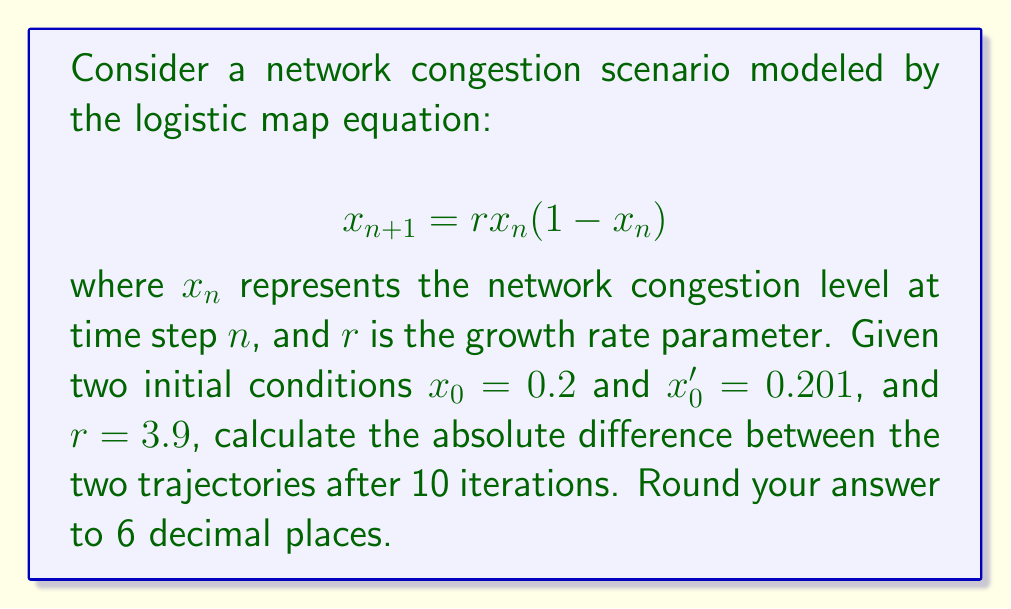Provide a solution to this math problem. To solve this problem, we need to iterate the logistic map equation for both initial conditions and compare the results:

1. For $x_0 = 0.2$:
   $x_1 = 3.9 \times 0.2 \times (1 - 0.2) = 0.624$
   $x_2 = 3.9 \times 0.624 \times (1 - 0.624) = 0.916324416$
   ...
   $x_{10} = 0.870271178$

2. For $x_0' = 0.201$:
   $x_1' = 3.9 \times 0.201 \times (1 - 0.201) = 0.626145$
   $x_2' = 3.9 \times 0.626145 \times (1 - 0.626145) = 0.916988625$
   ...
   $x_{10}' = 0.629372315$

3. Calculate the absolute difference:
   $|x_{10} - x_{10}'| = |0.870271178 - 0.629372315| = 0.240898863$

4. Round to 6 decimal places:
   $0.240898863 \approx 0.240899$

This result demonstrates the sensitivity to initial conditions in chaotic systems, where a small change in the initial state leads to a significant divergence in trajectories over time.
Answer: 0.240899 